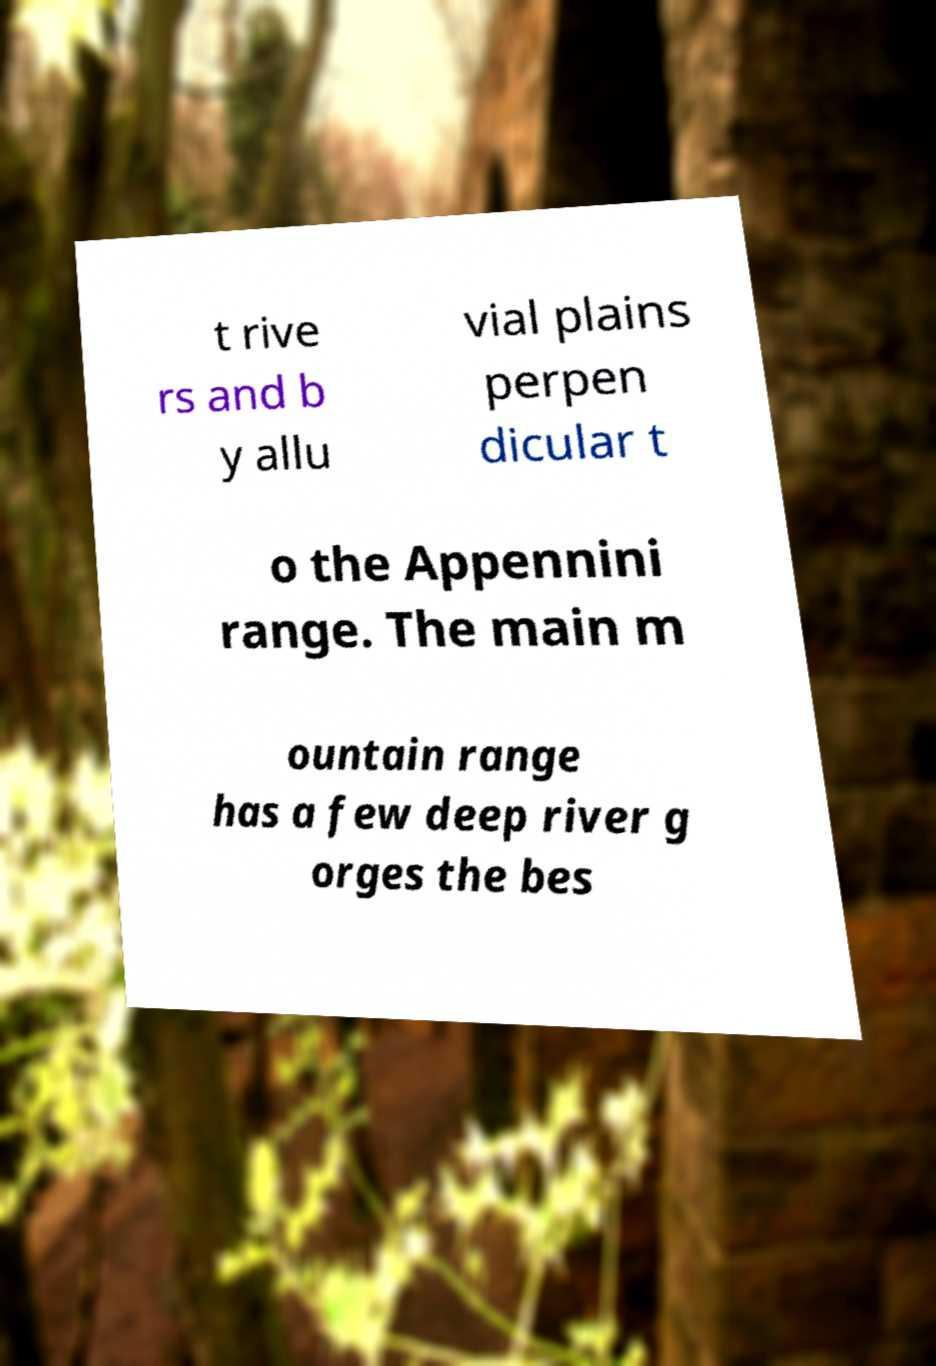Could you assist in decoding the text presented in this image and type it out clearly? t rive rs and b y allu vial plains perpen dicular t o the Appennini range. The main m ountain range has a few deep river g orges the bes 